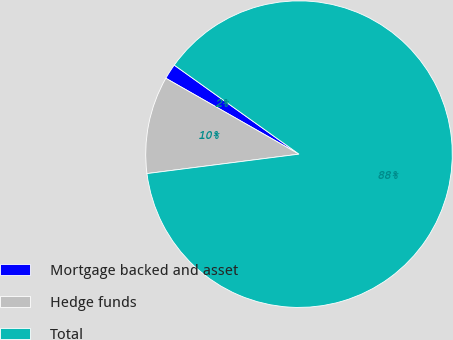Convert chart to OTSL. <chart><loc_0><loc_0><loc_500><loc_500><pie_chart><fcel>Mortgage backed and asset<fcel>Hedge funds<fcel>Total<nl><fcel>1.62%<fcel>10.27%<fcel>88.11%<nl></chart> 